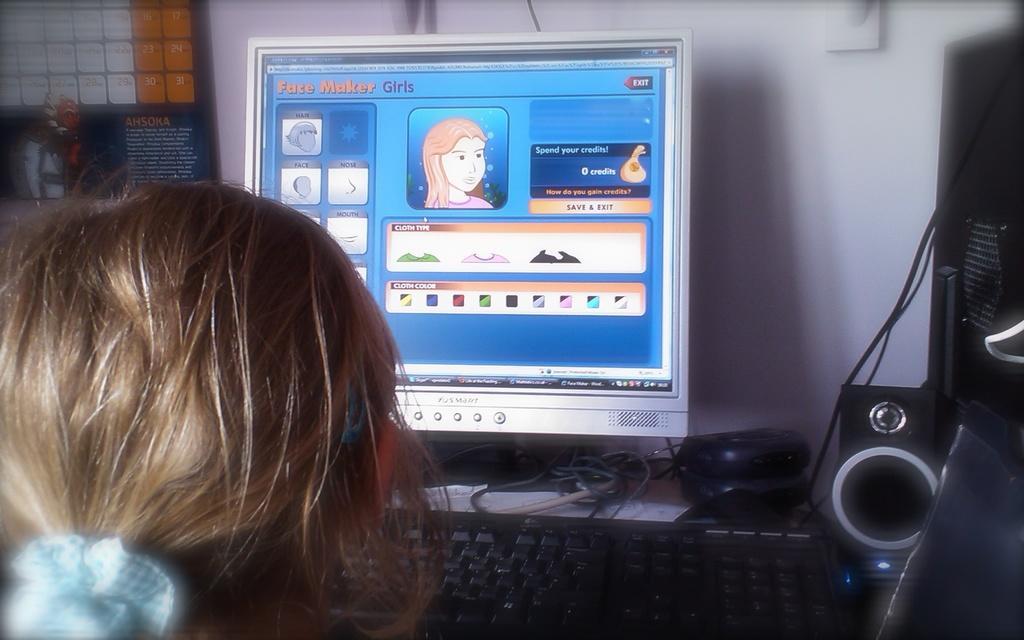Please provide a concise description of this image. In this image we can see a person sitting at the computer. On the table we can see mouse, keyboard, speaker, CPU. In the background there is a wall and calendar. 